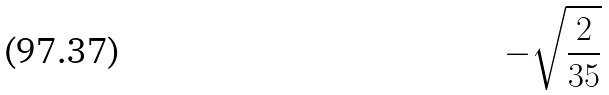Convert formula to latex. <formula><loc_0><loc_0><loc_500><loc_500>- \sqrt { \frac { 2 } { 3 5 } }</formula> 